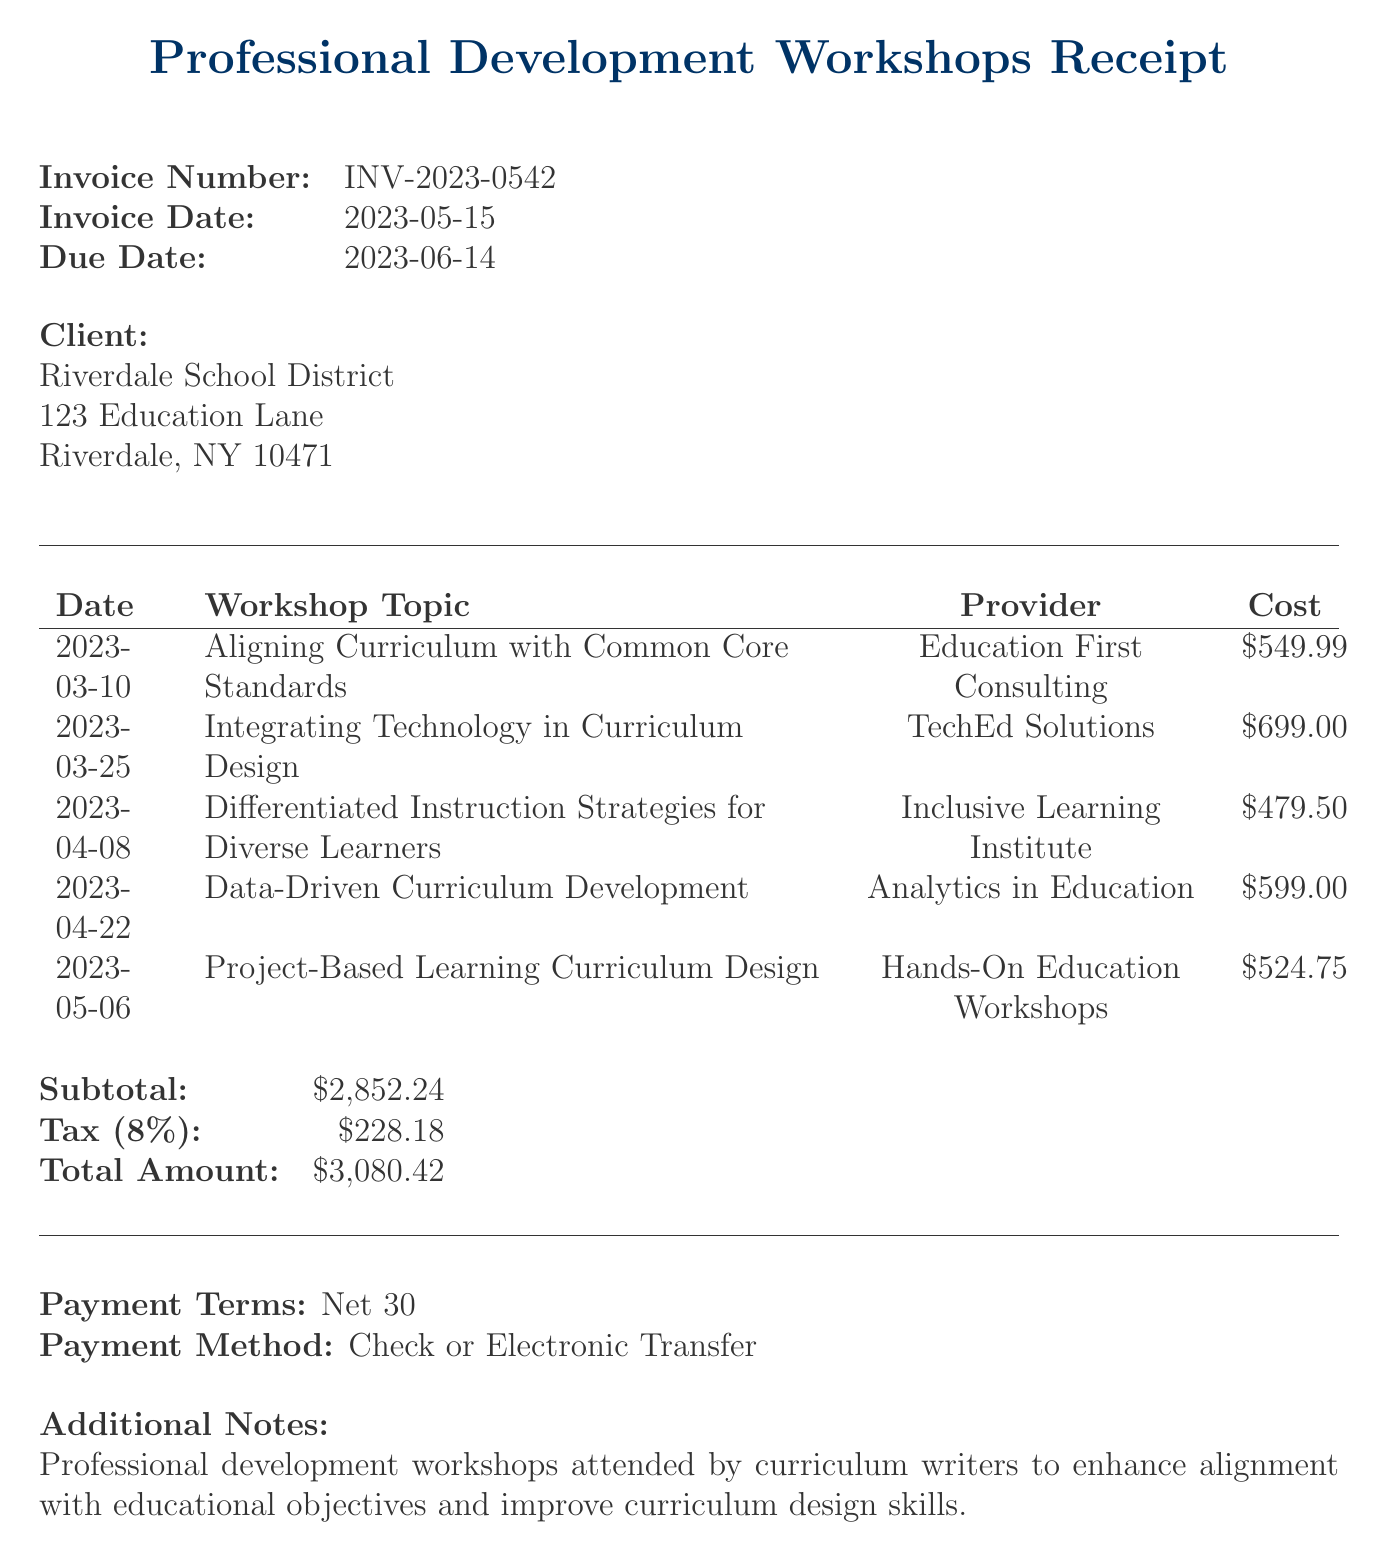What is the invoice number? The invoice number is a unique identifier for the document, provided at the top of the invoice.
Answer: INV-2023-0542 What is the total amount due? The total amount due is the final figure calculated after adding the subtotal and tax.
Answer: $3,080.42 Who is the client? The client is the entity to whom the invoice is issued, specified in the client section.
Answer: Riverdale School District What is the date of the last workshop? The date of the last workshop is important to understand the timeline of professional development.
Answer: 2023-05-06 How much was spent on the workshop about technology integration? The cost of each workshop is listed, allowing for easy retrieval of individual expenses.
Answer: $699.00 How many workshops were attended in total? The number of workshops attended can be counted from the list provided in the invoice.
Answer: 5 What payment method is accepted? The payment method section specifies how payment can be made for the services rendered.
Answer: Check or Electronic Transfer What is the tax rate applied to the invoice? The tax rate is specified in the document, affecting the total amount due.
Answer: 8% What is the due date for payment? The due date gives the timeframe for when the payment must be made.
Answer: 2023-06-14 What type of workshops were mentioned in the additional notes? The additional notes summarize the purpose and focus of the workshops for clarity.
Answer: Professional development workshops 